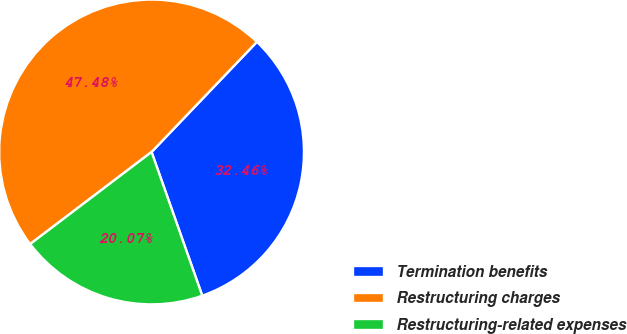<chart> <loc_0><loc_0><loc_500><loc_500><pie_chart><fcel>Termination benefits<fcel>Restructuring charges<fcel>Restructuring-related expenses<nl><fcel>32.46%<fcel>47.48%<fcel>20.07%<nl></chart> 